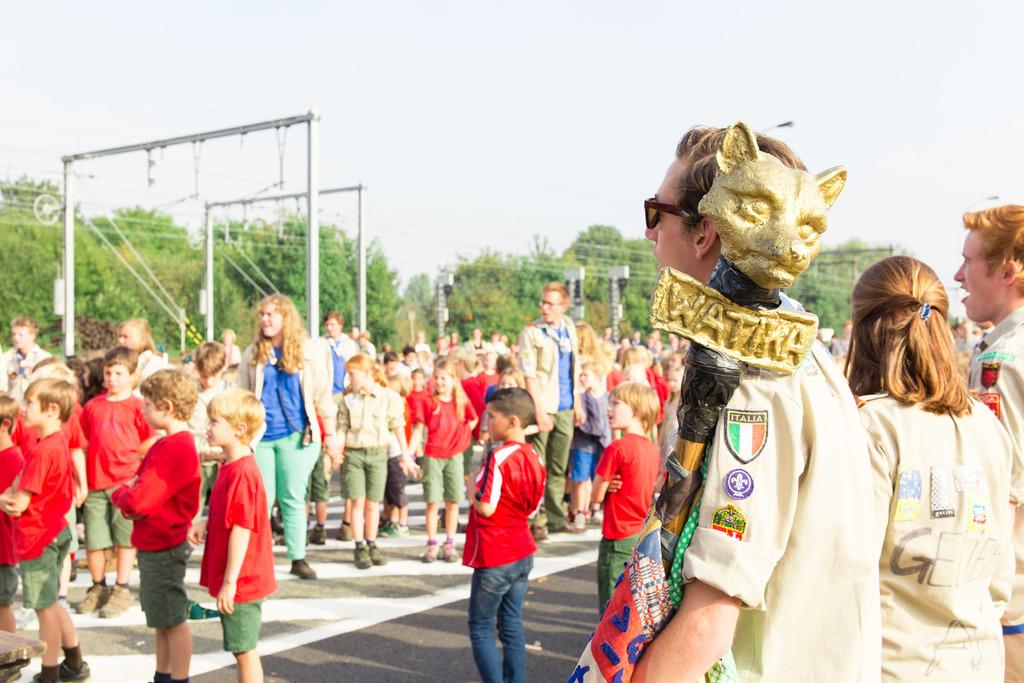What is happening in the image? There is a group of people in the image, and they are standing. Can you describe the clothing of some people in the image? Some people in the image are wearing red color t-shirts. What can be seen in the background of the image? There are poles, cables, and trees in the background of the image. How many beds are visible in the image? There are no beds present in the image. What type of whip is being used by the people in the image? There is no whip present in the image; the people are simply standing. 